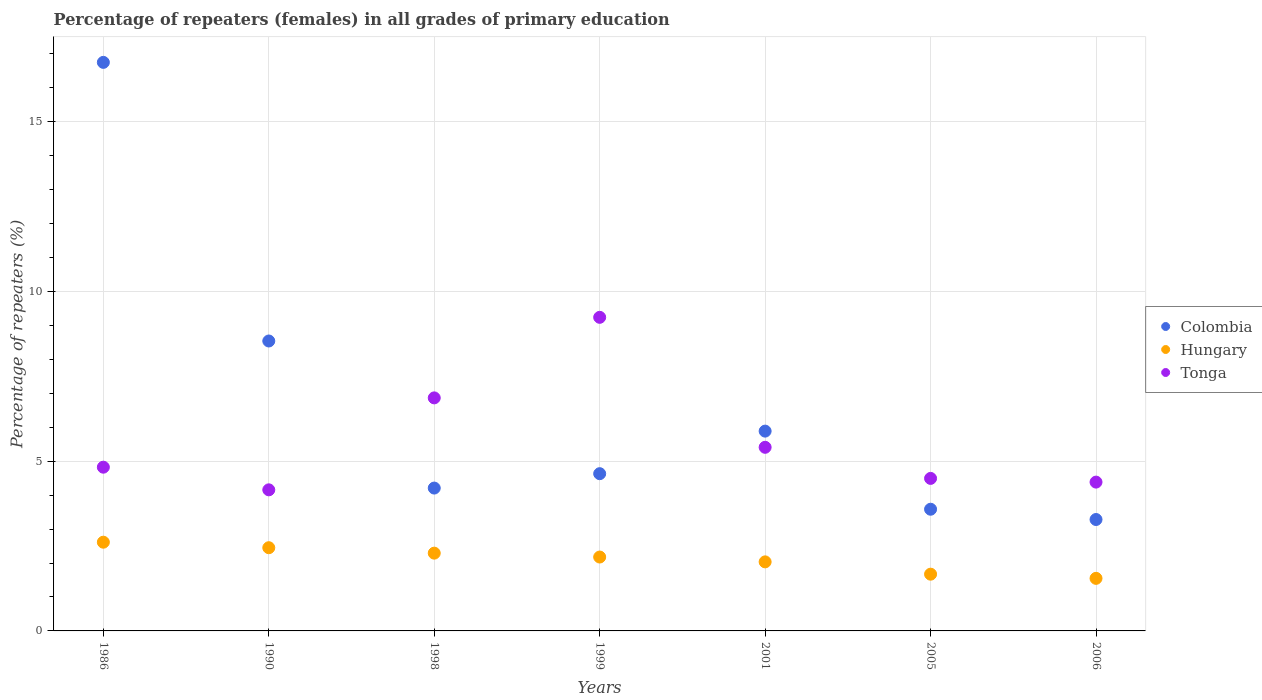Is the number of dotlines equal to the number of legend labels?
Offer a very short reply. Yes. What is the percentage of repeaters (females) in Tonga in 1986?
Offer a terse response. 4.82. Across all years, what is the maximum percentage of repeaters (females) in Hungary?
Your answer should be very brief. 2.61. Across all years, what is the minimum percentage of repeaters (females) in Tonga?
Make the answer very short. 4.16. In which year was the percentage of repeaters (females) in Colombia minimum?
Provide a succinct answer. 2006. What is the total percentage of repeaters (females) in Tonga in the graph?
Your response must be concise. 39.37. What is the difference between the percentage of repeaters (females) in Tonga in 1990 and that in 2001?
Offer a very short reply. -1.25. What is the difference between the percentage of repeaters (females) in Colombia in 1999 and the percentage of repeaters (females) in Tonga in 2005?
Provide a short and direct response. 0.14. What is the average percentage of repeaters (females) in Hungary per year?
Your answer should be compact. 2.11. In the year 2001, what is the difference between the percentage of repeaters (females) in Hungary and percentage of repeaters (females) in Colombia?
Your response must be concise. -3.85. What is the ratio of the percentage of repeaters (females) in Colombia in 1986 to that in 2006?
Provide a succinct answer. 5.1. What is the difference between the highest and the second highest percentage of repeaters (females) in Tonga?
Make the answer very short. 2.37. What is the difference between the highest and the lowest percentage of repeaters (females) in Colombia?
Offer a very short reply. 13.47. Is the sum of the percentage of repeaters (females) in Tonga in 1986 and 1998 greater than the maximum percentage of repeaters (females) in Colombia across all years?
Offer a very short reply. No. Is it the case that in every year, the sum of the percentage of repeaters (females) in Tonga and percentage of repeaters (females) in Colombia  is greater than the percentage of repeaters (females) in Hungary?
Your answer should be very brief. Yes. Does the percentage of repeaters (females) in Hungary monotonically increase over the years?
Provide a short and direct response. No. What is the difference between two consecutive major ticks on the Y-axis?
Your answer should be compact. 5. Does the graph contain grids?
Ensure brevity in your answer.  Yes. How are the legend labels stacked?
Ensure brevity in your answer.  Vertical. What is the title of the graph?
Offer a very short reply. Percentage of repeaters (females) in all grades of primary education. Does "Andorra" appear as one of the legend labels in the graph?
Give a very brief answer. No. What is the label or title of the Y-axis?
Ensure brevity in your answer.  Percentage of repeaters (%). What is the Percentage of repeaters (%) of Colombia in 1986?
Your answer should be very brief. 16.75. What is the Percentage of repeaters (%) of Hungary in 1986?
Offer a terse response. 2.61. What is the Percentage of repeaters (%) in Tonga in 1986?
Offer a very short reply. 4.82. What is the Percentage of repeaters (%) of Colombia in 1990?
Provide a succinct answer. 8.54. What is the Percentage of repeaters (%) of Hungary in 1990?
Keep it short and to the point. 2.45. What is the Percentage of repeaters (%) of Tonga in 1990?
Your answer should be compact. 4.16. What is the Percentage of repeaters (%) of Colombia in 1998?
Your answer should be very brief. 4.21. What is the Percentage of repeaters (%) in Hungary in 1998?
Keep it short and to the point. 2.29. What is the Percentage of repeaters (%) of Tonga in 1998?
Your response must be concise. 6.87. What is the Percentage of repeaters (%) in Colombia in 1999?
Keep it short and to the point. 4.63. What is the Percentage of repeaters (%) of Hungary in 1999?
Provide a short and direct response. 2.18. What is the Percentage of repeaters (%) in Tonga in 1999?
Keep it short and to the point. 9.24. What is the Percentage of repeaters (%) of Colombia in 2001?
Keep it short and to the point. 5.89. What is the Percentage of repeaters (%) of Hungary in 2001?
Your answer should be compact. 2.03. What is the Percentage of repeaters (%) in Tonga in 2001?
Your answer should be compact. 5.41. What is the Percentage of repeaters (%) of Colombia in 2005?
Ensure brevity in your answer.  3.59. What is the Percentage of repeaters (%) of Hungary in 2005?
Your answer should be compact. 1.67. What is the Percentage of repeaters (%) in Tonga in 2005?
Offer a very short reply. 4.49. What is the Percentage of repeaters (%) of Colombia in 2006?
Offer a terse response. 3.28. What is the Percentage of repeaters (%) of Hungary in 2006?
Offer a very short reply. 1.55. What is the Percentage of repeaters (%) in Tonga in 2006?
Give a very brief answer. 4.38. Across all years, what is the maximum Percentage of repeaters (%) of Colombia?
Provide a short and direct response. 16.75. Across all years, what is the maximum Percentage of repeaters (%) of Hungary?
Your response must be concise. 2.61. Across all years, what is the maximum Percentage of repeaters (%) of Tonga?
Give a very brief answer. 9.24. Across all years, what is the minimum Percentage of repeaters (%) in Colombia?
Your answer should be very brief. 3.28. Across all years, what is the minimum Percentage of repeaters (%) in Hungary?
Keep it short and to the point. 1.55. Across all years, what is the minimum Percentage of repeaters (%) in Tonga?
Your answer should be compact. 4.16. What is the total Percentage of repeaters (%) in Colombia in the graph?
Your answer should be compact. 46.89. What is the total Percentage of repeaters (%) of Hungary in the graph?
Offer a terse response. 14.79. What is the total Percentage of repeaters (%) in Tonga in the graph?
Offer a terse response. 39.37. What is the difference between the Percentage of repeaters (%) in Colombia in 1986 and that in 1990?
Make the answer very short. 8.21. What is the difference between the Percentage of repeaters (%) in Hungary in 1986 and that in 1990?
Provide a succinct answer. 0.16. What is the difference between the Percentage of repeaters (%) in Tonga in 1986 and that in 1990?
Offer a terse response. 0.67. What is the difference between the Percentage of repeaters (%) in Colombia in 1986 and that in 1998?
Offer a very short reply. 12.54. What is the difference between the Percentage of repeaters (%) in Hungary in 1986 and that in 1998?
Ensure brevity in your answer.  0.32. What is the difference between the Percentage of repeaters (%) in Tonga in 1986 and that in 1998?
Keep it short and to the point. -2.04. What is the difference between the Percentage of repeaters (%) in Colombia in 1986 and that in 1999?
Give a very brief answer. 12.12. What is the difference between the Percentage of repeaters (%) in Hungary in 1986 and that in 1999?
Your answer should be very brief. 0.44. What is the difference between the Percentage of repeaters (%) of Tonga in 1986 and that in 1999?
Your answer should be very brief. -4.42. What is the difference between the Percentage of repeaters (%) of Colombia in 1986 and that in 2001?
Provide a short and direct response. 10.86. What is the difference between the Percentage of repeaters (%) in Hungary in 1986 and that in 2001?
Make the answer very short. 0.58. What is the difference between the Percentage of repeaters (%) in Tonga in 1986 and that in 2001?
Offer a very short reply. -0.59. What is the difference between the Percentage of repeaters (%) in Colombia in 1986 and that in 2005?
Your answer should be compact. 13.17. What is the difference between the Percentage of repeaters (%) in Hungary in 1986 and that in 2005?
Keep it short and to the point. 0.94. What is the difference between the Percentage of repeaters (%) of Tonga in 1986 and that in 2005?
Give a very brief answer. 0.33. What is the difference between the Percentage of repeaters (%) of Colombia in 1986 and that in 2006?
Ensure brevity in your answer.  13.47. What is the difference between the Percentage of repeaters (%) in Hungary in 1986 and that in 2006?
Give a very brief answer. 1.07. What is the difference between the Percentage of repeaters (%) in Tonga in 1986 and that in 2006?
Offer a terse response. 0.44. What is the difference between the Percentage of repeaters (%) in Colombia in 1990 and that in 1998?
Offer a very short reply. 4.33. What is the difference between the Percentage of repeaters (%) of Hungary in 1990 and that in 1998?
Give a very brief answer. 0.16. What is the difference between the Percentage of repeaters (%) of Tonga in 1990 and that in 1998?
Provide a succinct answer. -2.71. What is the difference between the Percentage of repeaters (%) in Colombia in 1990 and that in 1999?
Provide a short and direct response. 3.91. What is the difference between the Percentage of repeaters (%) of Hungary in 1990 and that in 1999?
Give a very brief answer. 0.27. What is the difference between the Percentage of repeaters (%) in Tonga in 1990 and that in 1999?
Make the answer very short. -5.08. What is the difference between the Percentage of repeaters (%) in Colombia in 1990 and that in 2001?
Offer a terse response. 2.66. What is the difference between the Percentage of repeaters (%) in Hungary in 1990 and that in 2001?
Your answer should be very brief. 0.42. What is the difference between the Percentage of repeaters (%) of Tonga in 1990 and that in 2001?
Give a very brief answer. -1.25. What is the difference between the Percentage of repeaters (%) of Colombia in 1990 and that in 2005?
Your answer should be compact. 4.96. What is the difference between the Percentage of repeaters (%) in Hungary in 1990 and that in 2005?
Make the answer very short. 0.78. What is the difference between the Percentage of repeaters (%) of Tonga in 1990 and that in 2005?
Your answer should be compact. -0.34. What is the difference between the Percentage of repeaters (%) of Colombia in 1990 and that in 2006?
Offer a very short reply. 5.26. What is the difference between the Percentage of repeaters (%) in Hungary in 1990 and that in 2006?
Provide a succinct answer. 0.9. What is the difference between the Percentage of repeaters (%) in Tonga in 1990 and that in 2006?
Give a very brief answer. -0.23. What is the difference between the Percentage of repeaters (%) of Colombia in 1998 and that in 1999?
Ensure brevity in your answer.  -0.42. What is the difference between the Percentage of repeaters (%) of Hungary in 1998 and that in 1999?
Your answer should be compact. 0.11. What is the difference between the Percentage of repeaters (%) of Tonga in 1998 and that in 1999?
Your response must be concise. -2.37. What is the difference between the Percentage of repeaters (%) of Colombia in 1998 and that in 2001?
Your response must be concise. -1.68. What is the difference between the Percentage of repeaters (%) of Hungary in 1998 and that in 2001?
Give a very brief answer. 0.26. What is the difference between the Percentage of repeaters (%) in Tonga in 1998 and that in 2001?
Offer a very short reply. 1.46. What is the difference between the Percentage of repeaters (%) of Colombia in 1998 and that in 2005?
Your answer should be compact. 0.62. What is the difference between the Percentage of repeaters (%) in Hungary in 1998 and that in 2005?
Ensure brevity in your answer.  0.62. What is the difference between the Percentage of repeaters (%) in Tonga in 1998 and that in 2005?
Ensure brevity in your answer.  2.37. What is the difference between the Percentage of repeaters (%) of Colombia in 1998 and that in 2006?
Keep it short and to the point. 0.93. What is the difference between the Percentage of repeaters (%) of Hungary in 1998 and that in 2006?
Offer a very short reply. 0.74. What is the difference between the Percentage of repeaters (%) in Tonga in 1998 and that in 2006?
Ensure brevity in your answer.  2.48. What is the difference between the Percentage of repeaters (%) of Colombia in 1999 and that in 2001?
Offer a very short reply. -1.25. What is the difference between the Percentage of repeaters (%) of Hungary in 1999 and that in 2001?
Offer a very short reply. 0.14. What is the difference between the Percentage of repeaters (%) of Tonga in 1999 and that in 2001?
Make the answer very short. 3.83. What is the difference between the Percentage of repeaters (%) of Colombia in 1999 and that in 2005?
Keep it short and to the point. 1.05. What is the difference between the Percentage of repeaters (%) of Hungary in 1999 and that in 2005?
Your response must be concise. 0.51. What is the difference between the Percentage of repeaters (%) of Tonga in 1999 and that in 2005?
Provide a succinct answer. 4.75. What is the difference between the Percentage of repeaters (%) of Colombia in 1999 and that in 2006?
Your answer should be very brief. 1.35. What is the difference between the Percentage of repeaters (%) of Hungary in 1999 and that in 2006?
Provide a succinct answer. 0.63. What is the difference between the Percentage of repeaters (%) in Tonga in 1999 and that in 2006?
Your response must be concise. 4.85. What is the difference between the Percentage of repeaters (%) in Colombia in 2001 and that in 2005?
Provide a short and direct response. 2.3. What is the difference between the Percentage of repeaters (%) of Hungary in 2001 and that in 2005?
Your answer should be compact. 0.36. What is the difference between the Percentage of repeaters (%) in Tonga in 2001 and that in 2005?
Provide a succinct answer. 0.92. What is the difference between the Percentage of repeaters (%) of Colombia in 2001 and that in 2006?
Provide a succinct answer. 2.6. What is the difference between the Percentage of repeaters (%) in Hungary in 2001 and that in 2006?
Your response must be concise. 0.49. What is the difference between the Percentage of repeaters (%) in Tonga in 2001 and that in 2006?
Your answer should be compact. 1.03. What is the difference between the Percentage of repeaters (%) in Colombia in 2005 and that in 2006?
Offer a terse response. 0.3. What is the difference between the Percentage of repeaters (%) in Hungary in 2005 and that in 2006?
Offer a very short reply. 0.12. What is the difference between the Percentage of repeaters (%) of Tonga in 2005 and that in 2006?
Offer a very short reply. 0.11. What is the difference between the Percentage of repeaters (%) in Colombia in 1986 and the Percentage of repeaters (%) in Hungary in 1990?
Give a very brief answer. 14.3. What is the difference between the Percentage of repeaters (%) of Colombia in 1986 and the Percentage of repeaters (%) of Tonga in 1990?
Your answer should be compact. 12.59. What is the difference between the Percentage of repeaters (%) in Hungary in 1986 and the Percentage of repeaters (%) in Tonga in 1990?
Your answer should be compact. -1.54. What is the difference between the Percentage of repeaters (%) of Colombia in 1986 and the Percentage of repeaters (%) of Hungary in 1998?
Give a very brief answer. 14.46. What is the difference between the Percentage of repeaters (%) of Colombia in 1986 and the Percentage of repeaters (%) of Tonga in 1998?
Give a very brief answer. 9.88. What is the difference between the Percentage of repeaters (%) of Hungary in 1986 and the Percentage of repeaters (%) of Tonga in 1998?
Keep it short and to the point. -4.25. What is the difference between the Percentage of repeaters (%) of Colombia in 1986 and the Percentage of repeaters (%) of Hungary in 1999?
Keep it short and to the point. 14.57. What is the difference between the Percentage of repeaters (%) in Colombia in 1986 and the Percentage of repeaters (%) in Tonga in 1999?
Your response must be concise. 7.51. What is the difference between the Percentage of repeaters (%) of Hungary in 1986 and the Percentage of repeaters (%) of Tonga in 1999?
Keep it short and to the point. -6.63. What is the difference between the Percentage of repeaters (%) in Colombia in 1986 and the Percentage of repeaters (%) in Hungary in 2001?
Offer a very short reply. 14.72. What is the difference between the Percentage of repeaters (%) of Colombia in 1986 and the Percentage of repeaters (%) of Tonga in 2001?
Keep it short and to the point. 11.34. What is the difference between the Percentage of repeaters (%) in Hungary in 1986 and the Percentage of repeaters (%) in Tonga in 2001?
Keep it short and to the point. -2.8. What is the difference between the Percentage of repeaters (%) in Colombia in 1986 and the Percentage of repeaters (%) in Hungary in 2005?
Provide a succinct answer. 15.08. What is the difference between the Percentage of repeaters (%) of Colombia in 1986 and the Percentage of repeaters (%) of Tonga in 2005?
Provide a short and direct response. 12.26. What is the difference between the Percentage of repeaters (%) in Hungary in 1986 and the Percentage of repeaters (%) in Tonga in 2005?
Provide a succinct answer. -1.88. What is the difference between the Percentage of repeaters (%) of Colombia in 1986 and the Percentage of repeaters (%) of Hungary in 2006?
Keep it short and to the point. 15.2. What is the difference between the Percentage of repeaters (%) of Colombia in 1986 and the Percentage of repeaters (%) of Tonga in 2006?
Provide a succinct answer. 12.37. What is the difference between the Percentage of repeaters (%) in Hungary in 1986 and the Percentage of repeaters (%) in Tonga in 2006?
Your response must be concise. -1.77. What is the difference between the Percentage of repeaters (%) of Colombia in 1990 and the Percentage of repeaters (%) of Hungary in 1998?
Your answer should be very brief. 6.25. What is the difference between the Percentage of repeaters (%) in Colombia in 1990 and the Percentage of repeaters (%) in Tonga in 1998?
Make the answer very short. 1.68. What is the difference between the Percentage of repeaters (%) in Hungary in 1990 and the Percentage of repeaters (%) in Tonga in 1998?
Your response must be concise. -4.41. What is the difference between the Percentage of repeaters (%) of Colombia in 1990 and the Percentage of repeaters (%) of Hungary in 1999?
Make the answer very short. 6.36. What is the difference between the Percentage of repeaters (%) of Colombia in 1990 and the Percentage of repeaters (%) of Tonga in 1999?
Give a very brief answer. -0.7. What is the difference between the Percentage of repeaters (%) of Hungary in 1990 and the Percentage of repeaters (%) of Tonga in 1999?
Make the answer very short. -6.79. What is the difference between the Percentage of repeaters (%) in Colombia in 1990 and the Percentage of repeaters (%) in Hungary in 2001?
Your answer should be very brief. 6.51. What is the difference between the Percentage of repeaters (%) in Colombia in 1990 and the Percentage of repeaters (%) in Tonga in 2001?
Ensure brevity in your answer.  3.13. What is the difference between the Percentage of repeaters (%) of Hungary in 1990 and the Percentage of repeaters (%) of Tonga in 2001?
Give a very brief answer. -2.96. What is the difference between the Percentage of repeaters (%) in Colombia in 1990 and the Percentage of repeaters (%) in Hungary in 2005?
Offer a very short reply. 6.87. What is the difference between the Percentage of repeaters (%) of Colombia in 1990 and the Percentage of repeaters (%) of Tonga in 2005?
Make the answer very short. 4.05. What is the difference between the Percentage of repeaters (%) in Hungary in 1990 and the Percentage of repeaters (%) in Tonga in 2005?
Provide a succinct answer. -2.04. What is the difference between the Percentage of repeaters (%) in Colombia in 1990 and the Percentage of repeaters (%) in Hungary in 2006?
Your answer should be very brief. 6.99. What is the difference between the Percentage of repeaters (%) of Colombia in 1990 and the Percentage of repeaters (%) of Tonga in 2006?
Keep it short and to the point. 4.16. What is the difference between the Percentage of repeaters (%) of Hungary in 1990 and the Percentage of repeaters (%) of Tonga in 2006?
Your answer should be compact. -1.93. What is the difference between the Percentage of repeaters (%) in Colombia in 1998 and the Percentage of repeaters (%) in Hungary in 1999?
Make the answer very short. 2.03. What is the difference between the Percentage of repeaters (%) of Colombia in 1998 and the Percentage of repeaters (%) of Tonga in 1999?
Provide a succinct answer. -5.03. What is the difference between the Percentage of repeaters (%) in Hungary in 1998 and the Percentage of repeaters (%) in Tonga in 1999?
Your answer should be very brief. -6.95. What is the difference between the Percentage of repeaters (%) of Colombia in 1998 and the Percentage of repeaters (%) of Hungary in 2001?
Your response must be concise. 2.17. What is the difference between the Percentage of repeaters (%) of Colombia in 1998 and the Percentage of repeaters (%) of Tonga in 2001?
Provide a short and direct response. -1.2. What is the difference between the Percentage of repeaters (%) of Hungary in 1998 and the Percentage of repeaters (%) of Tonga in 2001?
Ensure brevity in your answer.  -3.12. What is the difference between the Percentage of repeaters (%) of Colombia in 1998 and the Percentage of repeaters (%) of Hungary in 2005?
Your answer should be very brief. 2.54. What is the difference between the Percentage of repeaters (%) of Colombia in 1998 and the Percentage of repeaters (%) of Tonga in 2005?
Keep it short and to the point. -0.28. What is the difference between the Percentage of repeaters (%) in Hungary in 1998 and the Percentage of repeaters (%) in Tonga in 2005?
Make the answer very short. -2.2. What is the difference between the Percentage of repeaters (%) in Colombia in 1998 and the Percentage of repeaters (%) in Hungary in 2006?
Your response must be concise. 2.66. What is the difference between the Percentage of repeaters (%) in Colombia in 1998 and the Percentage of repeaters (%) in Tonga in 2006?
Provide a succinct answer. -0.18. What is the difference between the Percentage of repeaters (%) of Hungary in 1998 and the Percentage of repeaters (%) of Tonga in 2006?
Your answer should be very brief. -2.09. What is the difference between the Percentage of repeaters (%) of Colombia in 1999 and the Percentage of repeaters (%) of Hungary in 2001?
Provide a short and direct response. 2.6. What is the difference between the Percentage of repeaters (%) in Colombia in 1999 and the Percentage of repeaters (%) in Tonga in 2001?
Give a very brief answer. -0.78. What is the difference between the Percentage of repeaters (%) in Hungary in 1999 and the Percentage of repeaters (%) in Tonga in 2001?
Provide a succinct answer. -3.23. What is the difference between the Percentage of repeaters (%) in Colombia in 1999 and the Percentage of repeaters (%) in Hungary in 2005?
Your answer should be very brief. 2.96. What is the difference between the Percentage of repeaters (%) in Colombia in 1999 and the Percentage of repeaters (%) in Tonga in 2005?
Keep it short and to the point. 0.14. What is the difference between the Percentage of repeaters (%) in Hungary in 1999 and the Percentage of repeaters (%) in Tonga in 2005?
Make the answer very short. -2.32. What is the difference between the Percentage of repeaters (%) of Colombia in 1999 and the Percentage of repeaters (%) of Hungary in 2006?
Make the answer very short. 3.08. What is the difference between the Percentage of repeaters (%) in Colombia in 1999 and the Percentage of repeaters (%) in Tonga in 2006?
Offer a very short reply. 0.25. What is the difference between the Percentage of repeaters (%) of Hungary in 1999 and the Percentage of repeaters (%) of Tonga in 2006?
Your answer should be compact. -2.21. What is the difference between the Percentage of repeaters (%) of Colombia in 2001 and the Percentage of repeaters (%) of Hungary in 2005?
Ensure brevity in your answer.  4.21. What is the difference between the Percentage of repeaters (%) of Colombia in 2001 and the Percentage of repeaters (%) of Tonga in 2005?
Your response must be concise. 1.39. What is the difference between the Percentage of repeaters (%) in Hungary in 2001 and the Percentage of repeaters (%) in Tonga in 2005?
Make the answer very short. -2.46. What is the difference between the Percentage of repeaters (%) of Colombia in 2001 and the Percentage of repeaters (%) of Hungary in 2006?
Provide a short and direct response. 4.34. What is the difference between the Percentage of repeaters (%) of Colombia in 2001 and the Percentage of repeaters (%) of Tonga in 2006?
Keep it short and to the point. 1.5. What is the difference between the Percentage of repeaters (%) of Hungary in 2001 and the Percentage of repeaters (%) of Tonga in 2006?
Provide a short and direct response. -2.35. What is the difference between the Percentage of repeaters (%) in Colombia in 2005 and the Percentage of repeaters (%) in Hungary in 2006?
Provide a short and direct response. 2.04. What is the difference between the Percentage of repeaters (%) of Colombia in 2005 and the Percentage of repeaters (%) of Tonga in 2006?
Keep it short and to the point. -0.8. What is the difference between the Percentage of repeaters (%) of Hungary in 2005 and the Percentage of repeaters (%) of Tonga in 2006?
Ensure brevity in your answer.  -2.71. What is the average Percentage of repeaters (%) of Colombia per year?
Your response must be concise. 6.7. What is the average Percentage of repeaters (%) in Hungary per year?
Ensure brevity in your answer.  2.11. What is the average Percentage of repeaters (%) in Tonga per year?
Offer a terse response. 5.62. In the year 1986, what is the difference between the Percentage of repeaters (%) in Colombia and Percentage of repeaters (%) in Hungary?
Your answer should be very brief. 14.14. In the year 1986, what is the difference between the Percentage of repeaters (%) of Colombia and Percentage of repeaters (%) of Tonga?
Your response must be concise. 11.93. In the year 1986, what is the difference between the Percentage of repeaters (%) of Hungary and Percentage of repeaters (%) of Tonga?
Your answer should be compact. -2.21. In the year 1990, what is the difference between the Percentage of repeaters (%) of Colombia and Percentage of repeaters (%) of Hungary?
Keep it short and to the point. 6.09. In the year 1990, what is the difference between the Percentage of repeaters (%) in Colombia and Percentage of repeaters (%) in Tonga?
Make the answer very short. 4.39. In the year 1990, what is the difference between the Percentage of repeaters (%) in Hungary and Percentage of repeaters (%) in Tonga?
Make the answer very short. -1.71. In the year 1998, what is the difference between the Percentage of repeaters (%) of Colombia and Percentage of repeaters (%) of Hungary?
Make the answer very short. 1.92. In the year 1998, what is the difference between the Percentage of repeaters (%) of Colombia and Percentage of repeaters (%) of Tonga?
Your answer should be very brief. -2.66. In the year 1998, what is the difference between the Percentage of repeaters (%) in Hungary and Percentage of repeaters (%) in Tonga?
Your answer should be very brief. -4.57. In the year 1999, what is the difference between the Percentage of repeaters (%) of Colombia and Percentage of repeaters (%) of Hungary?
Your answer should be compact. 2.46. In the year 1999, what is the difference between the Percentage of repeaters (%) of Colombia and Percentage of repeaters (%) of Tonga?
Offer a terse response. -4.61. In the year 1999, what is the difference between the Percentage of repeaters (%) of Hungary and Percentage of repeaters (%) of Tonga?
Your response must be concise. -7.06. In the year 2001, what is the difference between the Percentage of repeaters (%) of Colombia and Percentage of repeaters (%) of Hungary?
Offer a terse response. 3.85. In the year 2001, what is the difference between the Percentage of repeaters (%) of Colombia and Percentage of repeaters (%) of Tonga?
Offer a terse response. 0.48. In the year 2001, what is the difference between the Percentage of repeaters (%) of Hungary and Percentage of repeaters (%) of Tonga?
Offer a very short reply. -3.38. In the year 2005, what is the difference between the Percentage of repeaters (%) in Colombia and Percentage of repeaters (%) in Hungary?
Your response must be concise. 1.91. In the year 2005, what is the difference between the Percentage of repeaters (%) of Colombia and Percentage of repeaters (%) of Tonga?
Offer a terse response. -0.91. In the year 2005, what is the difference between the Percentage of repeaters (%) of Hungary and Percentage of repeaters (%) of Tonga?
Make the answer very short. -2.82. In the year 2006, what is the difference between the Percentage of repeaters (%) of Colombia and Percentage of repeaters (%) of Hungary?
Keep it short and to the point. 1.73. In the year 2006, what is the difference between the Percentage of repeaters (%) of Colombia and Percentage of repeaters (%) of Tonga?
Your answer should be very brief. -1.1. In the year 2006, what is the difference between the Percentage of repeaters (%) in Hungary and Percentage of repeaters (%) in Tonga?
Keep it short and to the point. -2.84. What is the ratio of the Percentage of repeaters (%) of Colombia in 1986 to that in 1990?
Provide a short and direct response. 1.96. What is the ratio of the Percentage of repeaters (%) of Hungary in 1986 to that in 1990?
Your answer should be compact. 1.07. What is the ratio of the Percentage of repeaters (%) in Tonga in 1986 to that in 1990?
Offer a very short reply. 1.16. What is the ratio of the Percentage of repeaters (%) of Colombia in 1986 to that in 1998?
Your response must be concise. 3.98. What is the ratio of the Percentage of repeaters (%) of Hungary in 1986 to that in 1998?
Offer a very short reply. 1.14. What is the ratio of the Percentage of repeaters (%) of Tonga in 1986 to that in 1998?
Keep it short and to the point. 0.7. What is the ratio of the Percentage of repeaters (%) of Colombia in 1986 to that in 1999?
Provide a succinct answer. 3.62. What is the ratio of the Percentage of repeaters (%) in Hungary in 1986 to that in 1999?
Your answer should be compact. 1.2. What is the ratio of the Percentage of repeaters (%) of Tonga in 1986 to that in 1999?
Give a very brief answer. 0.52. What is the ratio of the Percentage of repeaters (%) in Colombia in 1986 to that in 2001?
Your response must be concise. 2.85. What is the ratio of the Percentage of repeaters (%) of Hungary in 1986 to that in 2001?
Offer a very short reply. 1.28. What is the ratio of the Percentage of repeaters (%) in Tonga in 1986 to that in 2001?
Make the answer very short. 0.89. What is the ratio of the Percentage of repeaters (%) in Colombia in 1986 to that in 2005?
Give a very brief answer. 4.67. What is the ratio of the Percentage of repeaters (%) of Hungary in 1986 to that in 2005?
Make the answer very short. 1.56. What is the ratio of the Percentage of repeaters (%) in Tonga in 1986 to that in 2005?
Provide a succinct answer. 1.07. What is the ratio of the Percentage of repeaters (%) in Colombia in 1986 to that in 2006?
Keep it short and to the point. 5.1. What is the ratio of the Percentage of repeaters (%) in Hungary in 1986 to that in 2006?
Provide a short and direct response. 1.69. What is the ratio of the Percentage of repeaters (%) of Tonga in 1986 to that in 2006?
Offer a very short reply. 1.1. What is the ratio of the Percentage of repeaters (%) in Colombia in 1990 to that in 1998?
Give a very brief answer. 2.03. What is the ratio of the Percentage of repeaters (%) in Hungary in 1990 to that in 1998?
Provide a short and direct response. 1.07. What is the ratio of the Percentage of repeaters (%) in Tonga in 1990 to that in 1998?
Make the answer very short. 0.61. What is the ratio of the Percentage of repeaters (%) in Colombia in 1990 to that in 1999?
Your response must be concise. 1.84. What is the ratio of the Percentage of repeaters (%) in Hungary in 1990 to that in 1999?
Your response must be concise. 1.13. What is the ratio of the Percentage of repeaters (%) of Tonga in 1990 to that in 1999?
Your answer should be compact. 0.45. What is the ratio of the Percentage of repeaters (%) of Colombia in 1990 to that in 2001?
Make the answer very short. 1.45. What is the ratio of the Percentage of repeaters (%) in Hungary in 1990 to that in 2001?
Keep it short and to the point. 1.21. What is the ratio of the Percentage of repeaters (%) of Tonga in 1990 to that in 2001?
Ensure brevity in your answer.  0.77. What is the ratio of the Percentage of repeaters (%) in Colombia in 1990 to that in 2005?
Provide a short and direct response. 2.38. What is the ratio of the Percentage of repeaters (%) in Hungary in 1990 to that in 2005?
Give a very brief answer. 1.47. What is the ratio of the Percentage of repeaters (%) of Tonga in 1990 to that in 2005?
Your answer should be very brief. 0.93. What is the ratio of the Percentage of repeaters (%) in Colombia in 1990 to that in 2006?
Your answer should be compact. 2.6. What is the ratio of the Percentage of repeaters (%) of Hungary in 1990 to that in 2006?
Provide a short and direct response. 1.58. What is the ratio of the Percentage of repeaters (%) of Tonga in 1990 to that in 2006?
Offer a very short reply. 0.95. What is the ratio of the Percentage of repeaters (%) in Colombia in 1998 to that in 1999?
Offer a terse response. 0.91. What is the ratio of the Percentage of repeaters (%) in Hungary in 1998 to that in 1999?
Provide a short and direct response. 1.05. What is the ratio of the Percentage of repeaters (%) in Tonga in 1998 to that in 1999?
Keep it short and to the point. 0.74. What is the ratio of the Percentage of repeaters (%) of Colombia in 1998 to that in 2001?
Your response must be concise. 0.71. What is the ratio of the Percentage of repeaters (%) in Hungary in 1998 to that in 2001?
Provide a short and direct response. 1.13. What is the ratio of the Percentage of repeaters (%) in Tonga in 1998 to that in 2001?
Offer a very short reply. 1.27. What is the ratio of the Percentage of repeaters (%) of Colombia in 1998 to that in 2005?
Keep it short and to the point. 1.17. What is the ratio of the Percentage of repeaters (%) of Hungary in 1998 to that in 2005?
Provide a short and direct response. 1.37. What is the ratio of the Percentage of repeaters (%) of Tonga in 1998 to that in 2005?
Your answer should be compact. 1.53. What is the ratio of the Percentage of repeaters (%) of Colombia in 1998 to that in 2006?
Provide a short and direct response. 1.28. What is the ratio of the Percentage of repeaters (%) in Hungary in 1998 to that in 2006?
Give a very brief answer. 1.48. What is the ratio of the Percentage of repeaters (%) in Tonga in 1998 to that in 2006?
Keep it short and to the point. 1.57. What is the ratio of the Percentage of repeaters (%) in Colombia in 1999 to that in 2001?
Offer a very short reply. 0.79. What is the ratio of the Percentage of repeaters (%) in Hungary in 1999 to that in 2001?
Keep it short and to the point. 1.07. What is the ratio of the Percentage of repeaters (%) in Tonga in 1999 to that in 2001?
Provide a short and direct response. 1.71. What is the ratio of the Percentage of repeaters (%) in Colombia in 1999 to that in 2005?
Provide a succinct answer. 1.29. What is the ratio of the Percentage of repeaters (%) of Hungary in 1999 to that in 2005?
Give a very brief answer. 1.3. What is the ratio of the Percentage of repeaters (%) in Tonga in 1999 to that in 2005?
Offer a very short reply. 2.06. What is the ratio of the Percentage of repeaters (%) in Colombia in 1999 to that in 2006?
Ensure brevity in your answer.  1.41. What is the ratio of the Percentage of repeaters (%) in Hungary in 1999 to that in 2006?
Your response must be concise. 1.41. What is the ratio of the Percentage of repeaters (%) of Tonga in 1999 to that in 2006?
Your answer should be very brief. 2.11. What is the ratio of the Percentage of repeaters (%) in Colombia in 2001 to that in 2005?
Your response must be concise. 1.64. What is the ratio of the Percentage of repeaters (%) of Hungary in 2001 to that in 2005?
Give a very brief answer. 1.22. What is the ratio of the Percentage of repeaters (%) in Tonga in 2001 to that in 2005?
Ensure brevity in your answer.  1.2. What is the ratio of the Percentage of repeaters (%) in Colombia in 2001 to that in 2006?
Your response must be concise. 1.79. What is the ratio of the Percentage of repeaters (%) in Hungary in 2001 to that in 2006?
Offer a terse response. 1.31. What is the ratio of the Percentage of repeaters (%) of Tonga in 2001 to that in 2006?
Provide a short and direct response. 1.23. What is the ratio of the Percentage of repeaters (%) of Colombia in 2005 to that in 2006?
Provide a short and direct response. 1.09. What is the ratio of the Percentage of repeaters (%) in Hungary in 2005 to that in 2006?
Make the answer very short. 1.08. What is the ratio of the Percentage of repeaters (%) of Tonga in 2005 to that in 2006?
Provide a succinct answer. 1.02. What is the difference between the highest and the second highest Percentage of repeaters (%) in Colombia?
Provide a succinct answer. 8.21. What is the difference between the highest and the second highest Percentage of repeaters (%) in Hungary?
Your response must be concise. 0.16. What is the difference between the highest and the second highest Percentage of repeaters (%) in Tonga?
Offer a terse response. 2.37. What is the difference between the highest and the lowest Percentage of repeaters (%) in Colombia?
Provide a succinct answer. 13.47. What is the difference between the highest and the lowest Percentage of repeaters (%) of Hungary?
Keep it short and to the point. 1.07. What is the difference between the highest and the lowest Percentage of repeaters (%) of Tonga?
Your answer should be compact. 5.08. 